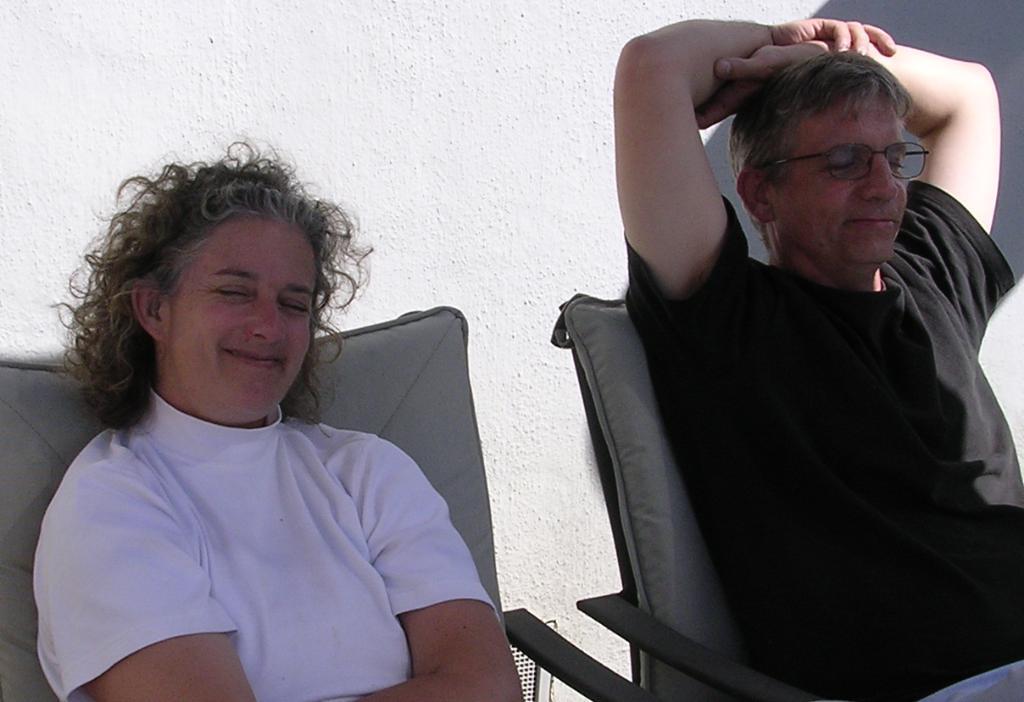Could you give a brief overview of what you see in this image? In this image I can see there are two persons sitting on the chair and smiling. And at the back there is a wall. 